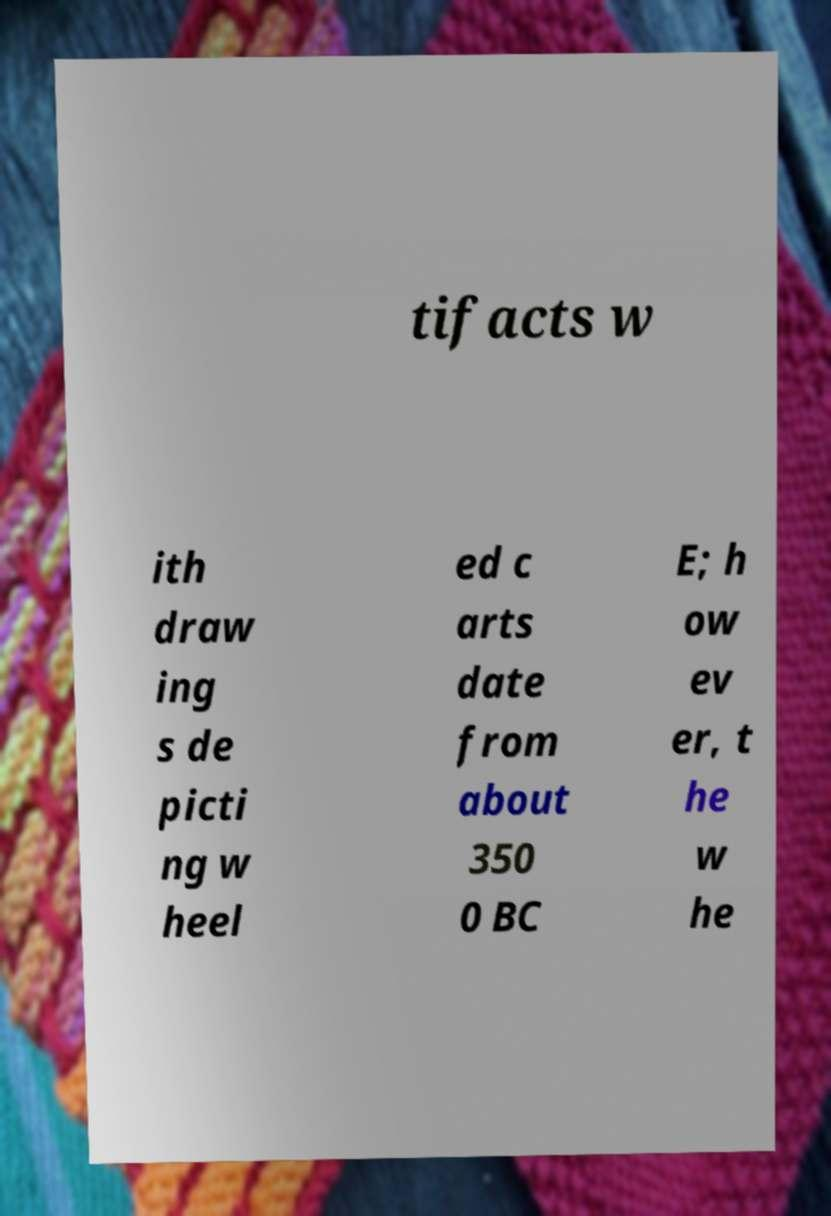There's text embedded in this image that I need extracted. Can you transcribe it verbatim? tifacts w ith draw ing s de picti ng w heel ed c arts date from about 350 0 BC E; h ow ev er, t he w he 